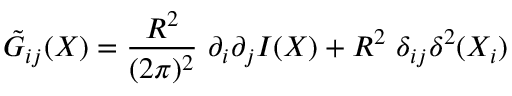<formula> <loc_0><loc_0><loc_500><loc_500>\tilde { G } _ { i j } ( X ) = \frac { { R } ^ { 2 } } { ( 2 \pi ) ^ { 2 } } \ \partial _ { i } \partial _ { j } I ( X ) + { R } ^ { 2 } \ \delta _ { i j } \delta ^ { 2 } ( X _ { i } )</formula> 